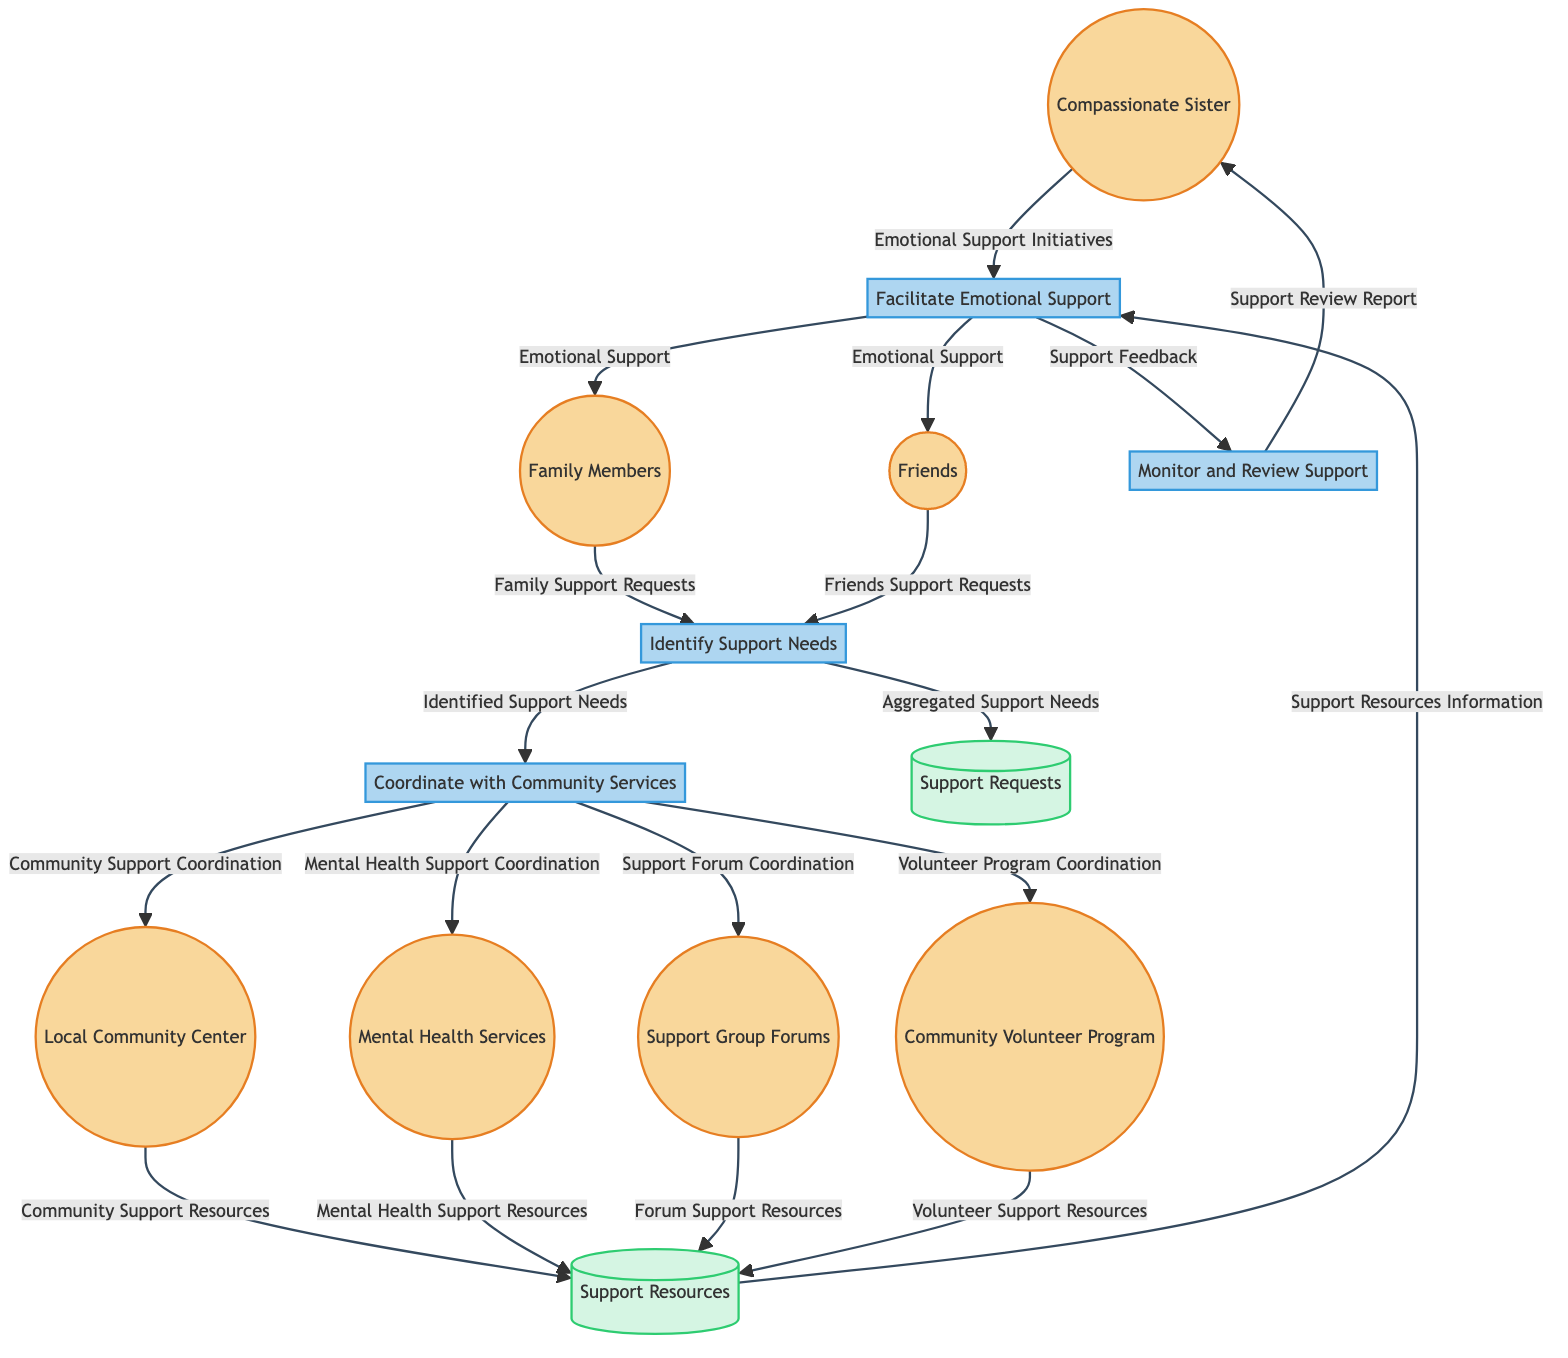What external entity initiates the support request process? The support request process is initiated by Family Members and Friends, who provide their respective support requests to the "Identify Support Needs" process.
Answer: Family Members, Friends How many processes are present in the diagram? The diagram contains four processes: "Identify Support Needs," "Coordinate with Community Services," "Facilitate Emotional Support," and "Monitor and Review Support."
Answer: Four What type of data is stored in the "Support Requests" data store? The "Support Requests" data store contains "Aggregated Support Needs" that come from the "Identify Support Needs" process, which aggregates input from Family Members and Friends.
Answer: Aggregated Support Needs Which external entity collaborates with "Community Volunteer Program"? The "Coordinate with Community Services" process collaborates with the "Community Volunteer Program" to facilitate volunteer program coordination, according to the data flow.
Answer: Coordinate with Community Services What is the output of the "Facilitate Emotional Support" process? The output of the "Facilitate Emotional Support" process is "Emotional Support," which is provided to both Family Members and Friends as support initiatives.
Answer: Emotional Support Where do community support resources come from according to the diagram? Community support resources come from the "Local Community Center," which sends its resources to the "Support Resources" data store.
Answer: Local Community Center What flows from the "Support Resources" data store to "Facilitate Emotional Support"? The flow from the "Support Resources" data store to "Facilitate Emotional Support" is "Support Resources Information," which is detailed information needed to provide emotional support.
Answer: Support Resources Information What is monitored in the "Monitor and Review Support" process? The "Monitor and Review Support" process monitors the "Support Feedback" that is provided from the "Facilitate Emotional Support" process to assess the effectiveness of the support given.
Answer: Support Feedback How many external entities are involved in the diagram? The diagram involves six external entities: Compassionate Sister, Family Members, Friends, Local Community Center, Mental Health Services, Support Group Forums, and Community Volunteer Program.
Answer: Six 